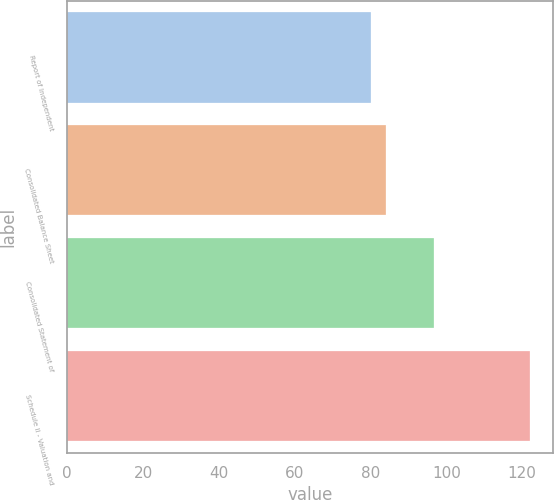Convert chart to OTSL. <chart><loc_0><loc_0><loc_500><loc_500><bar_chart><fcel>Report of Independent<fcel>Consolidated Balance Sheet<fcel>Consolidated Statement of<fcel>Schedule II - Valuation and<nl><fcel>80<fcel>84.2<fcel>96.8<fcel>122<nl></chart> 